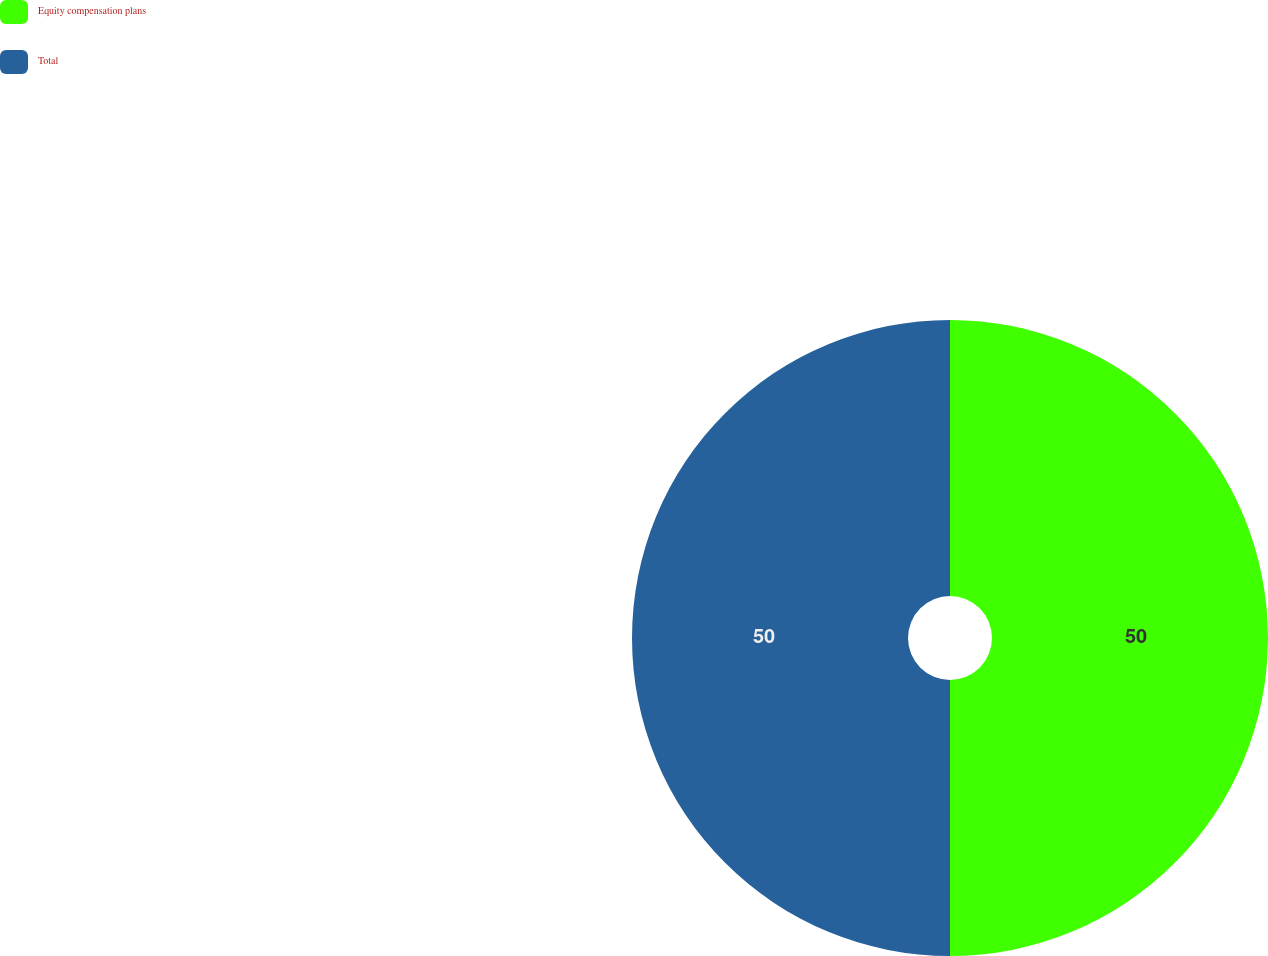Convert chart. <chart><loc_0><loc_0><loc_500><loc_500><pie_chart><fcel>Equity compensation plans<fcel>Total<nl><fcel>50.0%<fcel>50.0%<nl></chart> 